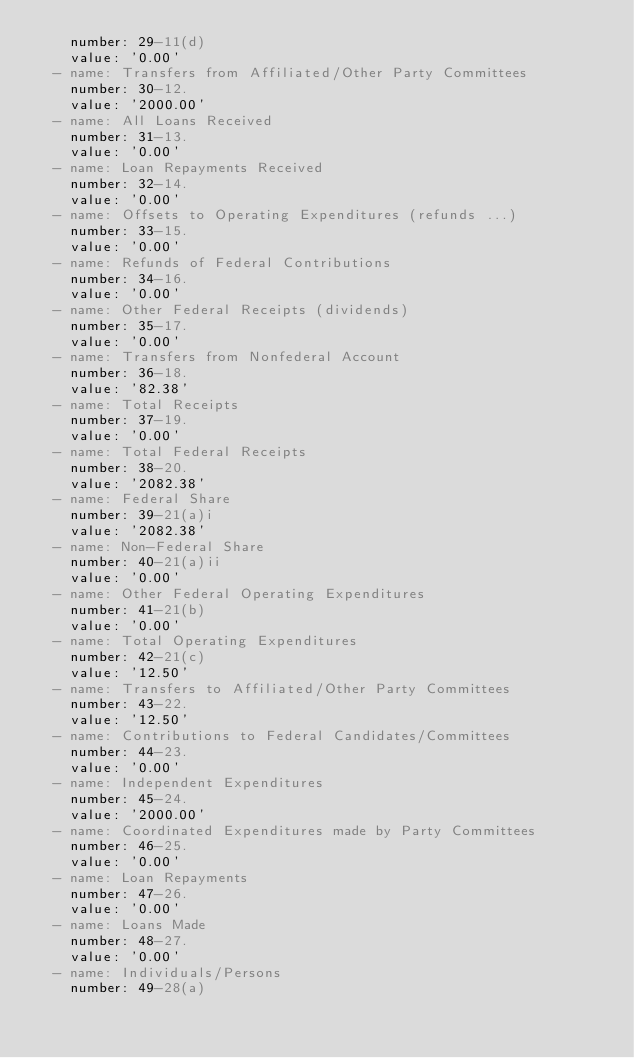<code> <loc_0><loc_0><loc_500><loc_500><_YAML_>    number: 29-11(d)
    value: '0.00'
  - name: Transfers from Affiliated/Other Party Committees
    number: 30-12.
    value: '2000.00'
  - name: All Loans Received
    number: 31-13.
    value: '0.00'
  - name: Loan Repayments Received
    number: 32-14.
    value: '0.00'
  - name: Offsets to Operating Expenditures (refunds ...)
    number: 33-15.
    value: '0.00'
  - name: Refunds of Federal Contributions
    number: 34-16.
    value: '0.00'
  - name: Other Federal Receipts (dividends)
    number: 35-17.
    value: '0.00'
  - name: Transfers from Nonfederal Account
    number: 36-18.
    value: '82.38'
  - name: Total Receipts
    number: 37-19.
    value: '0.00'
  - name: Total Federal Receipts
    number: 38-20.
    value: '2082.38'
  - name: Federal Share
    number: 39-21(a)i
    value: '2082.38'
  - name: Non-Federal Share
    number: 40-21(a)ii
    value: '0.00'
  - name: Other Federal Operating Expenditures
    number: 41-21(b)
    value: '0.00'
  - name: Total Operating Expenditures
    number: 42-21(c)
    value: '12.50'
  - name: Transfers to Affiliated/Other Party Committees
    number: 43-22.
    value: '12.50'
  - name: Contributions to Federal Candidates/Committees
    number: 44-23.
    value: '0.00'
  - name: Independent Expenditures
    number: 45-24.
    value: '2000.00'
  - name: Coordinated Expenditures made by Party Committees
    number: 46-25.
    value: '0.00'
  - name: Loan Repayments
    number: 47-26.
    value: '0.00'
  - name: Loans Made
    number: 48-27.
    value: '0.00'
  - name: Individuals/Persons
    number: 49-28(a)</code> 